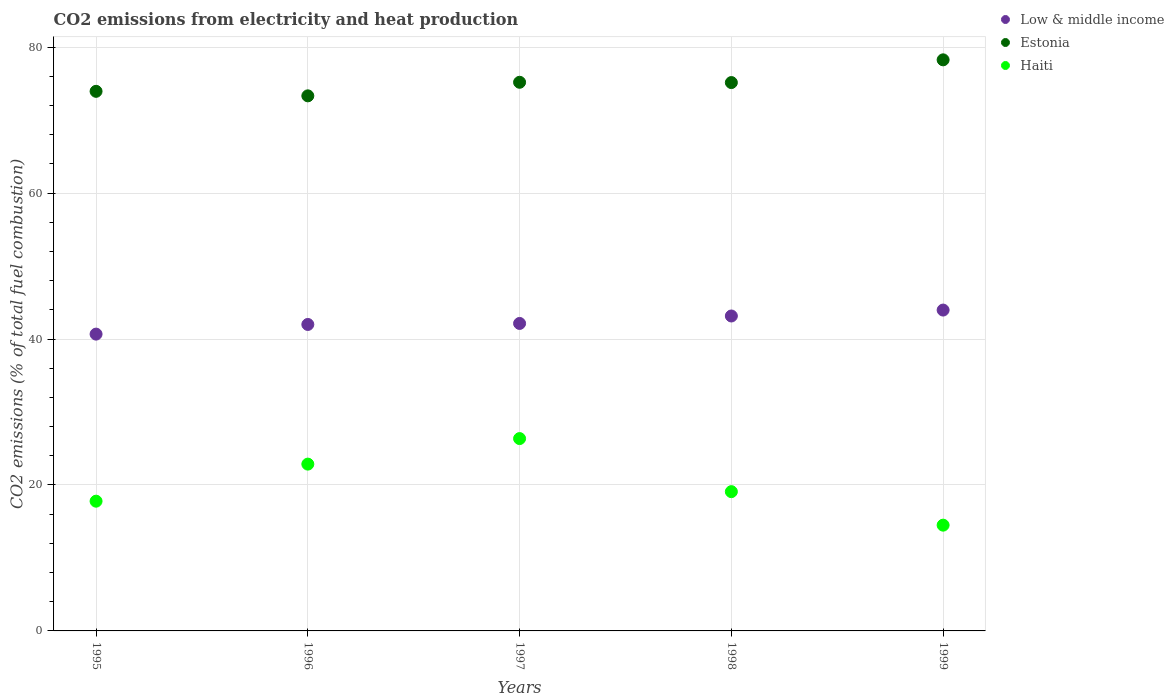How many different coloured dotlines are there?
Ensure brevity in your answer.  3. Is the number of dotlines equal to the number of legend labels?
Offer a very short reply. Yes. What is the amount of CO2 emitted in Haiti in 1995?
Offer a very short reply. 17.78. Across all years, what is the maximum amount of CO2 emitted in Low & middle income?
Make the answer very short. 43.97. Across all years, what is the minimum amount of CO2 emitted in Low & middle income?
Your answer should be very brief. 40.67. In which year was the amount of CO2 emitted in Estonia maximum?
Your response must be concise. 1999. In which year was the amount of CO2 emitted in Estonia minimum?
Ensure brevity in your answer.  1996. What is the total amount of CO2 emitted in Haiti in the graph?
Offer a terse response. 100.57. What is the difference between the amount of CO2 emitted in Estonia in 1995 and that in 1999?
Give a very brief answer. -4.31. What is the difference between the amount of CO2 emitted in Estonia in 1999 and the amount of CO2 emitted in Haiti in 1996?
Your answer should be very brief. 55.4. What is the average amount of CO2 emitted in Estonia per year?
Your answer should be compact. 75.17. In the year 1995, what is the difference between the amount of CO2 emitted in Estonia and amount of CO2 emitted in Low & middle income?
Offer a very short reply. 33.27. What is the ratio of the amount of CO2 emitted in Haiti in 1995 to that in 1997?
Provide a short and direct response. 0.67. Is the amount of CO2 emitted in Estonia in 1996 less than that in 1998?
Make the answer very short. Yes. What is the difference between the highest and the second highest amount of CO2 emitted in Estonia?
Your answer should be compact. 3.07. What is the difference between the highest and the lowest amount of CO2 emitted in Low & middle income?
Offer a very short reply. 3.3. Is the sum of the amount of CO2 emitted in Haiti in 1997 and 1999 greater than the maximum amount of CO2 emitted in Estonia across all years?
Ensure brevity in your answer.  No. Does the amount of CO2 emitted in Estonia monotonically increase over the years?
Your response must be concise. No. Is the amount of CO2 emitted in Haiti strictly less than the amount of CO2 emitted in Low & middle income over the years?
Ensure brevity in your answer.  Yes. How many dotlines are there?
Provide a succinct answer. 3. How many years are there in the graph?
Keep it short and to the point. 5. Are the values on the major ticks of Y-axis written in scientific E-notation?
Give a very brief answer. No. Where does the legend appear in the graph?
Make the answer very short. Top right. How many legend labels are there?
Provide a short and direct response. 3. What is the title of the graph?
Offer a terse response. CO2 emissions from electricity and heat production. What is the label or title of the X-axis?
Give a very brief answer. Years. What is the label or title of the Y-axis?
Offer a terse response. CO2 emissions (% of total fuel combustion). What is the CO2 emissions (% of total fuel combustion) of Low & middle income in 1995?
Offer a very short reply. 40.67. What is the CO2 emissions (% of total fuel combustion) in Estonia in 1995?
Keep it short and to the point. 73.94. What is the CO2 emissions (% of total fuel combustion) in Haiti in 1995?
Keep it short and to the point. 17.78. What is the CO2 emissions (% of total fuel combustion) of Low & middle income in 1996?
Keep it short and to the point. 41.99. What is the CO2 emissions (% of total fuel combustion) of Estonia in 1996?
Offer a very short reply. 73.32. What is the CO2 emissions (% of total fuel combustion) of Haiti in 1996?
Offer a very short reply. 22.86. What is the CO2 emissions (% of total fuel combustion) in Low & middle income in 1997?
Make the answer very short. 42.13. What is the CO2 emissions (% of total fuel combustion) in Estonia in 1997?
Keep it short and to the point. 75.18. What is the CO2 emissions (% of total fuel combustion) in Haiti in 1997?
Ensure brevity in your answer.  26.36. What is the CO2 emissions (% of total fuel combustion) in Low & middle income in 1998?
Your response must be concise. 43.16. What is the CO2 emissions (% of total fuel combustion) in Estonia in 1998?
Keep it short and to the point. 75.14. What is the CO2 emissions (% of total fuel combustion) of Haiti in 1998?
Give a very brief answer. 19.08. What is the CO2 emissions (% of total fuel combustion) of Low & middle income in 1999?
Your response must be concise. 43.97. What is the CO2 emissions (% of total fuel combustion) of Estonia in 1999?
Your answer should be very brief. 78.26. What is the CO2 emissions (% of total fuel combustion) in Haiti in 1999?
Keep it short and to the point. 14.49. Across all years, what is the maximum CO2 emissions (% of total fuel combustion) in Low & middle income?
Provide a succinct answer. 43.97. Across all years, what is the maximum CO2 emissions (% of total fuel combustion) of Estonia?
Keep it short and to the point. 78.26. Across all years, what is the maximum CO2 emissions (% of total fuel combustion) of Haiti?
Offer a terse response. 26.36. Across all years, what is the minimum CO2 emissions (% of total fuel combustion) of Low & middle income?
Offer a terse response. 40.67. Across all years, what is the minimum CO2 emissions (% of total fuel combustion) in Estonia?
Give a very brief answer. 73.32. Across all years, what is the minimum CO2 emissions (% of total fuel combustion) of Haiti?
Provide a short and direct response. 14.49. What is the total CO2 emissions (% of total fuel combustion) of Low & middle income in the graph?
Give a very brief answer. 211.92. What is the total CO2 emissions (% of total fuel combustion) of Estonia in the graph?
Give a very brief answer. 375.84. What is the total CO2 emissions (% of total fuel combustion) in Haiti in the graph?
Offer a terse response. 100.57. What is the difference between the CO2 emissions (% of total fuel combustion) in Low & middle income in 1995 and that in 1996?
Make the answer very short. -1.32. What is the difference between the CO2 emissions (% of total fuel combustion) of Estonia in 1995 and that in 1996?
Offer a very short reply. 0.62. What is the difference between the CO2 emissions (% of total fuel combustion) in Haiti in 1995 and that in 1996?
Provide a succinct answer. -5.08. What is the difference between the CO2 emissions (% of total fuel combustion) in Low & middle income in 1995 and that in 1997?
Offer a very short reply. -1.46. What is the difference between the CO2 emissions (% of total fuel combustion) in Estonia in 1995 and that in 1997?
Offer a very short reply. -1.24. What is the difference between the CO2 emissions (% of total fuel combustion) in Haiti in 1995 and that in 1997?
Your response must be concise. -8.58. What is the difference between the CO2 emissions (% of total fuel combustion) in Low & middle income in 1995 and that in 1998?
Offer a terse response. -2.48. What is the difference between the CO2 emissions (% of total fuel combustion) of Estonia in 1995 and that in 1998?
Offer a terse response. -1.2. What is the difference between the CO2 emissions (% of total fuel combustion) of Haiti in 1995 and that in 1998?
Provide a succinct answer. -1.31. What is the difference between the CO2 emissions (% of total fuel combustion) in Low & middle income in 1995 and that in 1999?
Give a very brief answer. -3.29. What is the difference between the CO2 emissions (% of total fuel combustion) in Estonia in 1995 and that in 1999?
Keep it short and to the point. -4.31. What is the difference between the CO2 emissions (% of total fuel combustion) of Haiti in 1995 and that in 1999?
Make the answer very short. 3.29. What is the difference between the CO2 emissions (% of total fuel combustion) of Low & middle income in 1996 and that in 1997?
Keep it short and to the point. -0.14. What is the difference between the CO2 emissions (% of total fuel combustion) of Estonia in 1996 and that in 1997?
Your response must be concise. -1.86. What is the difference between the CO2 emissions (% of total fuel combustion) of Haiti in 1996 and that in 1997?
Keep it short and to the point. -3.5. What is the difference between the CO2 emissions (% of total fuel combustion) in Low & middle income in 1996 and that in 1998?
Offer a very short reply. -1.16. What is the difference between the CO2 emissions (% of total fuel combustion) in Estonia in 1996 and that in 1998?
Ensure brevity in your answer.  -1.82. What is the difference between the CO2 emissions (% of total fuel combustion) of Haiti in 1996 and that in 1998?
Your answer should be compact. 3.77. What is the difference between the CO2 emissions (% of total fuel combustion) of Low & middle income in 1996 and that in 1999?
Offer a terse response. -1.97. What is the difference between the CO2 emissions (% of total fuel combustion) in Estonia in 1996 and that in 1999?
Provide a succinct answer. -4.93. What is the difference between the CO2 emissions (% of total fuel combustion) of Haiti in 1996 and that in 1999?
Ensure brevity in your answer.  8.36. What is the difference between the CO2 emissions (% of total fuel combustion) of Low & middle income in 1997 and that in 1998?
Make the answer very short. -1.02. What is the difference between the CO2 emissions (% of total fuel combustion) in Estonia in 1997 and that in 1998?
Provide a short and direct response. 0.04. What is the difference between the CO2 emissions (% of total fuel combustion) of Haiti in 1997 and that in 1998?
Give a very brief answer. 7.27. What is the difference between the CO2 emissions (% of total fuel combustion) of Low & middle income in 1997 and that in 1999?
Make the answer very short. -1.83. What is the difference between the CO2 emissions (% of total fuel combustion) in Estonia in 1997 and that in 1999?
Make the answer very short. -3.07. What is the difference between the CO2 emissions (% of total fuel combustion) in Haiti in 1997 and that in 1999?
Your response must be concise. 11.86. What is the difference between the CO2 emissions (% of total fuel combustion) in Low & middle income in 1998 and that in 1999?
Offer a terse response. -0.81. What is the difference between the CO2 emissions (% of total fuel combustion) of Estonia in 1998 and that in 1999?
Make the answer very short. -3.11. What is the difference between the CO2 emissions (% of total fuel combustion) of Haiti in 1998 and that in 1999?
Your answer should be compact. 4.59. What is the difference between the CO2 emissions (% of total fuel combustion) in Low & middle income in 1995 and the CO2 emissions (% of total fuel combustion) in Estonia in 1996?
Keep it short and to the point. -32.65. What is the difference between the CO2 emissions (% of total fuel combustion) of Low & middle income in 1995 and the CO2 emissions (% of total fuel combustion) of Haiti in 1996?
Give a very brief answer. 17.81. What is the difference between the CO2 emissions (% of total fuel combustion) of Estonia in 1995 and the CO2 emissions (% of total fuel combustion) of Haiti in 1996?
Ensure brevity in your answer.  51.08. What is the difference between the CO2 emissions (% of total fuel combustion) of Low & middle income in 1995 and the CO2 emissions (% of total fuel combustion) of Estonia in 1997?
Offer a terse response. -34.51. What is the difference between the CO2 emissions (% of total fuel combustion) of Low & middle income in 1995 and the CO2 emissions (% of total fuel combustion) of Haiti in 1997?
Provide a short and direct response. 14.31. What is the difference between the CO2 emissions (% of total fuel combustion) in Estonia in 1995 and the CO2 emissions (% of total fuel combustion) in Haiti in 1997?
Your answer should be very brief. 47.58. What is the difference between the CO2 emissions (% of total fuel combustion) of Low & middle income in 1995 and the CO2 emissions (% of total fuel combustion) of Estonia in 1998?
Keep it short and to the point. -34.47. What is the difference between the CO2 emissions (% of total fuel combustion) in Low & middle income in 1995 and the CO2 emissions (% of total fuel combustion) in Haiti in 1998?
Your answer should be very brief. 21.59. What is the difference between the CO2 emissions (% of total fuel combustion) in Estonia in 1995 and the CO2 emissions (% of total fuel combustion) in Haiti in 1998?
Provide a succinct answer. 54.86. What is the difference between the CO2 emissions (% of total fuel combustion) in Low & middle income in 1995 and the CO2 emissions (% of total fuel combustion) in Estonia in 1999?
Offer a terse response. -37.58. What is the difference between the CO2 emissions (% of total fuel combustion) in Low & middle income in 1995 and the CO2 emissions (% of total fuel combustion) in Haiti in 1999?
Give a very brief answer. 26.18. What is the difference between the CO2 emissions (% of total fuel combustion) in Estonia in 1995 and the CO2 emissions (% of total fuel combustion) in Haiti in 1999?
Your answer should be compact. 59.45. What is the difference between the CO2 emissions (% of total fuel combustion) of Low & middle income in 1996 and the CO2 emissions (% of total fuel combustion) of Estonia in 1997?
Give a very brief answer. -33.19. What is the difference between the CO2 emissions (% of total fuel combustion) of Low & middle income in 1996 and the CO2 emissions (% of total fuel combustion) of Haiti in 1997?
Make the answer very short. 15.64. What is the difference between the CO2 emissions (% of total fuel combustion) in Estonia in 1996 and the CO2 emissions (% of total fuel combustion) in Haiti in 1997?
Keep it short and to the point. 46.97. What is the difference between the CO2 emissions (% of total fuel combustion) in Low & middle income in 1996 and the CO2 emissions (% of total fuel combustion) in Estonia in 1998?
Make the answer very short. -33.15. What is the difference between the CO2 emissions (% of total fuel combustion) of Low & middle income in 1996 and the CO2 emissions (% of total fuel combustion) of Haiti in 1998?
Your response must be concise. 22.91. What is the difference between the CO2 emissions (% of total fuel combustion) in Estonia in 1996 and the CO2 emissions (% of total fuel combustion) in Haiti in 1998?
Give a very brief answer. 54.24. What is the difference between the CO2 emissions (% of total fuel combustion) of Low & middle income in 1996 and the CO2 emissions (% of total fuel combustion) of Estonia in 1999?
Make the answer very short. -36.26. What is the difference between the CO2 emissions (% of total fuel combustion) of Low & middle income in 1996 and the CO2 emissions (% of total fuel combustion) of Haiti in 1999?
Your answer should be very brief. 27.5. What is the difference between the CO2 emissions (% of total fuel combustion) in Estonia in 1996 and the CO2 emissions (% of total fuel combustion) in Haiti in 1999?
Your answer should be compact. 58.83. What is the difference between the CO2 emissions (% of total fuel combustion) of Low & middle income in 1997 and the CO2 emissions (% of total fuel combustion) of Estonia in 1998?
Offer a terse response. -33.01. What is the difference between the CO2 emissions (% of total fuel combustion) in Low & middle income in 1997 and the CO2 emissions (% of total fuel combustion) in Haiti in 1998?
Offer a terse response. 23.05. What is the difference between the CO2 emissions (% of total fuel combustion) of Estonia in 1997 and the CO2 emissions (% of total fuel combustion) of Haiti in 1998?
Your answer should be compact. 56.1. What is the difference between the CO2 emissions (% of total fuel combustion) in Low & middle income in 1997 and the CO2 emissions (% of total fuel combustion) in Estonia in 1999?
Offer a terse response. -36.12. What is the difference between the CO2 emissions (% of total fuel combustion) of Low & middle income in 1997 and the CO2 emissions (% of total fuel combustion) of Haiti in 1999?
Keep it short and to the point. 27.64. What is the difference between the CO2 emissions (% of total fuel combustion) in Estonia in 1997 and the CO2 emissions (% of total fuel combustion) in Haiti in 1999?
Keep it short and to the point. 60.69. What is the difference between the CO2 emissions (% of total fuel combustion) of Low & middle income in 1998 and the CO2 emissions (% of total fuel combustion) of Estonia in 1999?
Provide a short and direct response. -35.1. What is the difference between the CO2 emissions (% of total fuel combustion) of Low & middle income in 1998 and the CO2 emissions (% of total fuel combustion) of Haiti in 1999?
Offer a very short reply. 28.66. What is the difference between the CO2 emissions (% of total fuel combustion) of Estonia in 1998 and the CO2 emissions (% of total fuel combustion) of Haiti in 1999?
Ensure brevity in your answer.  60.65. What is the average CO2 emissions (% of total fuel combustion) of Low & middle income per year?
Your answer should be compact. 42.38. What is the average CO2 emissions (% of total fuel combustion) of Estonia per year?
Offer a terse response. 75.17. What is the average CO2 emissions (% of total fuel combustion) in Haiti per year?
Offer a very short reply. 20.11. In the year 1995, what is the difference between the CO2 emissions (% of total fuel combustion) in Low & middle income and CO2 emissions (% of total fuel combustion) in Estonia?
Make the answer very short. -33.27. In the year 1995, what is the difference between the CO2 emissions (% of total fuel combustion) of Low & middle income and CO2 emissions (% of total fuel combustion) of Haiti?
Provide a succinct answer. 22.89. In the year 1995, what is the difference between the CO2 emissions (% of total fuel combustion) in Estonia and CO2 emissions (% of total fuel combustion) in Haiti?
Your answer should be very brief. 56.16. In the year 1996, what is the difference between the CO2 emissions (% of total fuel combustion) in Low & middle income and CO2 emissions (% of total fuel combustion) in Estonia?
Provide a succinct answer. -31.33. In the year 1996, what is the difference between the CO2 emissions (% of total fuel combustion) in Low & middle income and CO2 emissions (% of total fuel combustion) in Haiti?
Your answer should be very brief. 19.14. In the year 1996, what is the difference between the CO2 emissions (% of total fuel combustion) of Estonia and CO2 emissions (% of total fuel combustion) of Haiti?
Make the answer very short. 50.46. In the year 1997, what is the difference between the CO2 emissions (% of total fuel combustion) of Low & middle income and CO2 emissions (% of total fuel combustion) of Estonia?
Provide a succinct answer. -33.05. In the year 1997, what is the difference between the CO2 emissions (% of total fuel combustion) in Low & middle income and CO2 emissions (% of total fuel combustion) in Haiti?
Make the answer very short. 15.78. In the year 1997, what is the difference between the CO2 emissions (% of total fuel combustion) in Estonia and CO2 emissions (% of total fuel combustion) in Haiti?
Provide a succinct answer. 48.82. In the year 1998, what is the difference between the CO2 emissions (% of total fuel combustion) of Low & middle income and CO2 emissions (% of total fuel combustion) of Estonia?
Keep it short and to the point. -31.99. In the year 1998, what is the difference between the CO2 emissions (% of total fuel combustion) of Low & middle income and CO2 emissions (% of total fuel combustion) of Haiti?
Offer a very short reply. 24.07. In the year 1998, what is the difference between the CO2 emissions (% of total fuel combustion) of Estonia and CO2 emissions (% of total fuel combustion) of Haiti?
Give a very brief answer. 56.06. In the year 1999, what is the difference between the CO2 emissions (% of total fuel combustion) in Low & middle income and CO2 emissions (% of total fuel combustion) in Estonia?
Offer a very short reply. -34.29. In the year 1999, what is the difference between the CO2 emissions (% of total fuel combustion) in Low & middle income and CO2 emissions (% of total fuel combustion) in Haiti?
Your answer should be compact. 29.47. In the year 1999, what is the difference between the CO2 emissions (% of total fuel combustion) of Estonia and CO2 emissions (% of total fuel combustion) of Haiti?
Give a very brief answer. 63.76. What is the ratio of the CO2 emissions (% of total fuel combustion) of Low & middle income in 1995 to that in 1996?
Provide a succinct answer. 0.97. What is the ratio of the CO2 emissions (% of total fuel combustion) of Estonia in 1995 to that in 1996?
Your response must be concise. 1.01. What is the ratio of the CO2 emissions (% of total fuel combustion) of Low & middle income in 1995 to that in 1997?
Make the answer very short. 0.97. What is the ratio of the CO2 emissions (% of total fuel combustion) in Estonia in 1995 to that in 1997?
Provide a short and direct response. 0.98. What is the ratio of the CO2 emissions (% of total fuel combustion) of Haiti in 1995 to that in 1997?
Offer a very short reply. 0.67. What is the ratio of the CO2 emissions (% of total fuel combustion) in Low & middle income in 1995 to that in 1998?
Ensure brevity in your answer.  0.94. What is the ratio of the CO2 emissions (% of total fuel combustion) of Estonia in 1995 to that in 1998?
Provide a short and direct response. 0.98. What is the ratio of the CO2 emissions (% of total fuel combustion) of Haiti in 1995 to that in 1998?
Offer a terse response. 0.93. What is the ratio of the CO2 emissions (% of total fuel combustion) of Low & middle income in 1995 to that in 1999?
Your response must be concise. 0.93. What is the ratio of the CO2 emissions (% of total fuel combustion) of Estonia in 1995 to that in 1999?
Make the answer very short. 0.94. What is the ratio of the CO2 emissions (% of total fuel combustion) in Haiti in 1995 to that in 1999?
Your answer should be very brief. 1.23. What is the ratio of the CO2 emissions (% of total fuel combustion) in Low & middle income in 1996 to that in 1997?
Provide a short and direct response. 1. What is the ratio of the CO2 emissions (% of total fuel combustion) of Estonia in 1996 to that in 1997?
Your response must be concise. 0.98. What is the ratio of the CO2 emissions (% of total fuel combustion) of Haiti in 1996 to that in 1997?
Your response must be concise. 0.87. What is the ratio of the CO2 emissions (% of total fuel combustion) in Low & middle income in 1996 to that in 1998?
Provide a succinct answer. 0.97. What is the ratio of the CO2 emissions (% of total fuel combustion) in Estonia in 1996 to that in 1998?
Provide a short and direct response. 0.98. What is the ratio of the CO2 emissions (% of total fuel combustion) of Haiti in 1996 to that in 1998?
Provide a succinct answer. 1.2. What is the ratio of the CO2 emissions (% of total fuel combustion) in Low & middle income in 1996 to that in 1999?
Provide a short and direct response. 0.96. What is the ratio of the CO2 emissions (% of total fuel combustion) of Estonia in 1996 to that in 1999?
Provide a short and direct response. 0.94. What is the ratio of the CO2 emissions (% of total fuel combustion) in Haiti in 1996 to that in 1999?
Your answer should be compact. 1.58. What is the ratio of the CO2 emissions (% of total fuel combustion) of Low & middle income in 1997 to that in 1998?
Provide a short and direct response. 0.98. What is the ratio of the CO2 emissions (% of total fuel combustion) of Haiti in 1997 to that in 1998?
Give a very brief answer. 1.38. What is the ratio of the CO2 emissions (% of total fuel combustion) in Estonia in 1997 to that in 1999?
Keep it short and to the point. 0.96. What is the ratio of the CO2 emissions (% of total fuel combustion) in Haiti in 1997 to that in 1999?
Ensure brevity in your answer.  1.82. What is the ratio of the CO2 emissions (% of total fuel combustion) in Low & middle income in 1998 to that in 1999?
Provide a succinct answer. 0.98. What is the ratio of the CO2 emissions (% of total fuel combustion) in Estonia in 1998 to that in 1999?
Your answer should be very brief. 0.96. What is the ratio of the CO2 emissions (% of total fuel combustion) in Haiti in 1998 to that in 1999?
Give a very brief answer. 1.32. What is the difference between the highest and the second highest CO2 emissions (% of total fuel combustion) of Low & middle income?
Offer a very short reply. 0.81. What is the difference between the highest and the second highest CO2 emissions (% of total fuel combustion) of Estonia?
Give a very brief answer. 3.07. What is the difference between the highest and the second highest CO2 emissions (% of total fuel combustion) of Haiti?
Provide a short and direct response. 3.5. What is the difference between the highest and the lowest CO2 emissions (% of total fuel combustion) of Low & middle income?
Offer a terse response. 3.29. What is the difference between the highest and the lowest CO2 emissions (% of total fuel combustion) in Estonia?
Your answer should be compact. 4.93. What is the difference between the highest and the lowest CO2 emissions (% of total fuel combustion) of Haiti?
Ensure brevity in your answer.  11.86. 